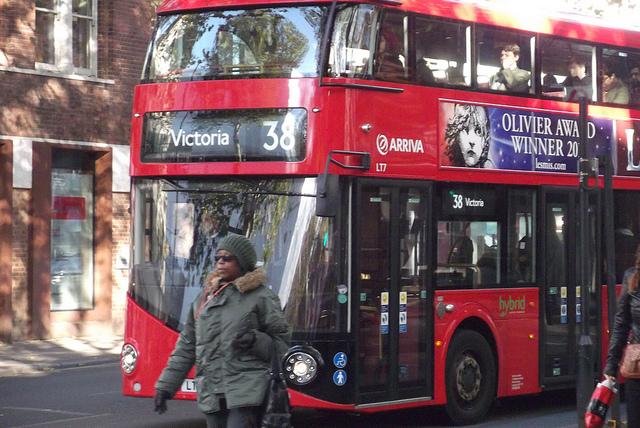Is it safe to ride in the top of the bus?
Be succinct. Yes. Where is this vehicle headed to?
Write a very short answer. Victoria. What color hat does this lady have on?
Write a very short answer. Gray. 